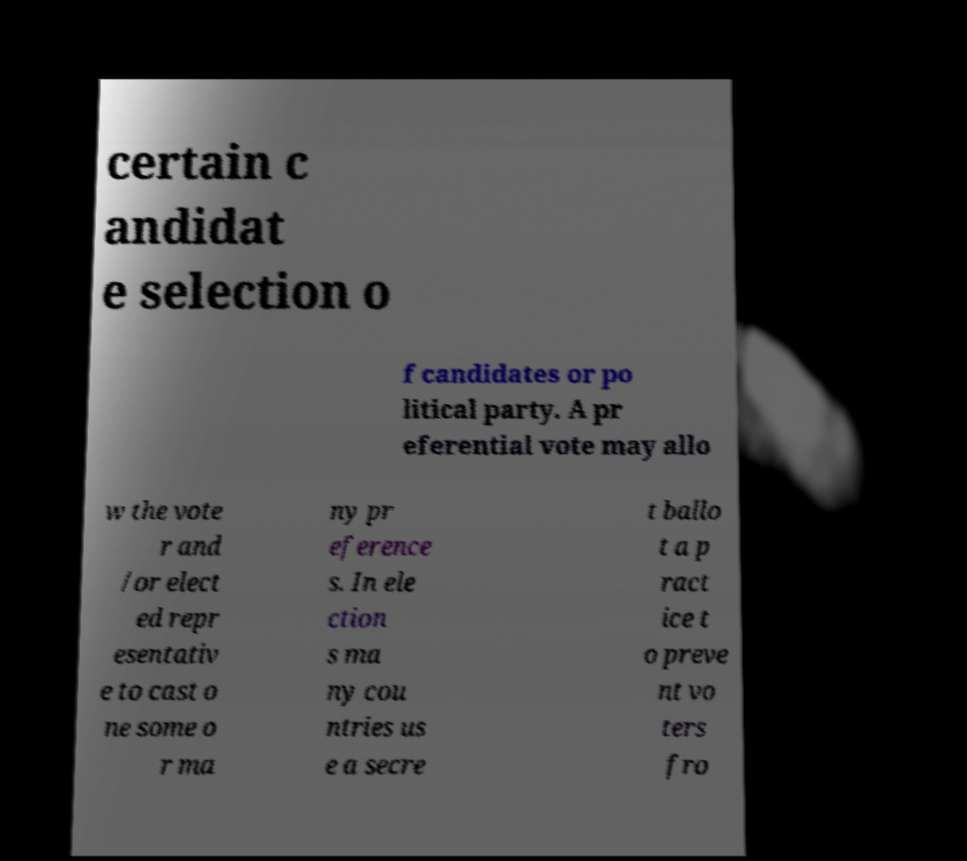Could you assist in decoding the text presented in this image and type it out clearly? certain c andidat e selection o f candidates or po litical party. A pr eferential vote may allo w the vote r and /or elect ed repr esentativ e to cast o ne some o r ma ny pr eference s. In ele ction s ma ny cou ntries us e a secre t ballo t a p ract ice t o preve nt vo ters fro 